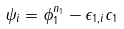<formula> <loc_0><loc_0><loc_500><loc_500>\psi _ { i } = \phi _ { 1 } ^ { n _ { 1 } } - \epsilon _ { 1 , i } c _ { 1 }</formula> 